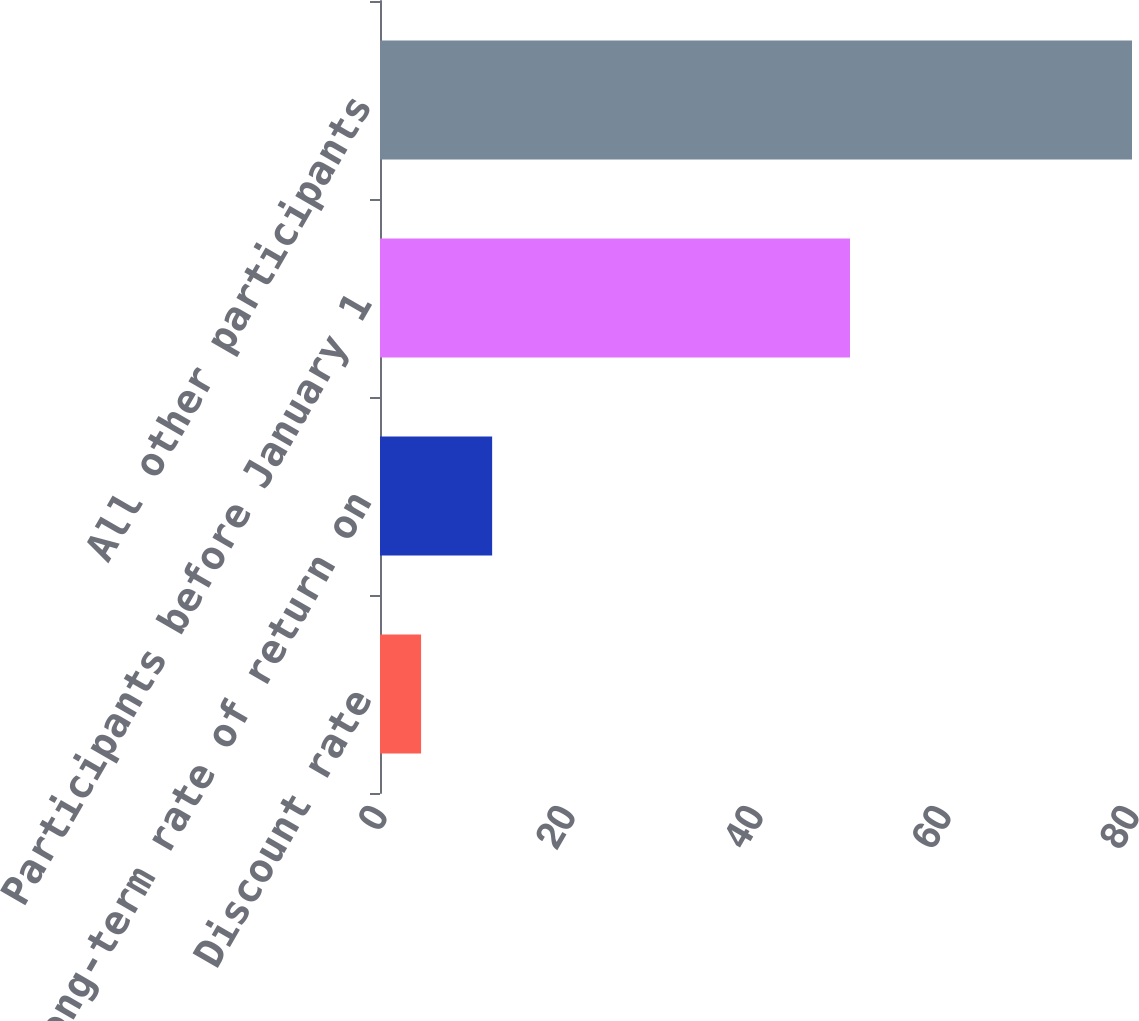Convert chart to OTSL. <chart><loc_0><loc_0><loc_500><loc_500><bar_chart><fcel>Discount rate<fcel>Long-term rate of return on<fcel>Participants before January 1<fcel>All other participants<nl><fcel>4.37<fcel>11.93<fcel>50<fcel>80<nl></chart> 